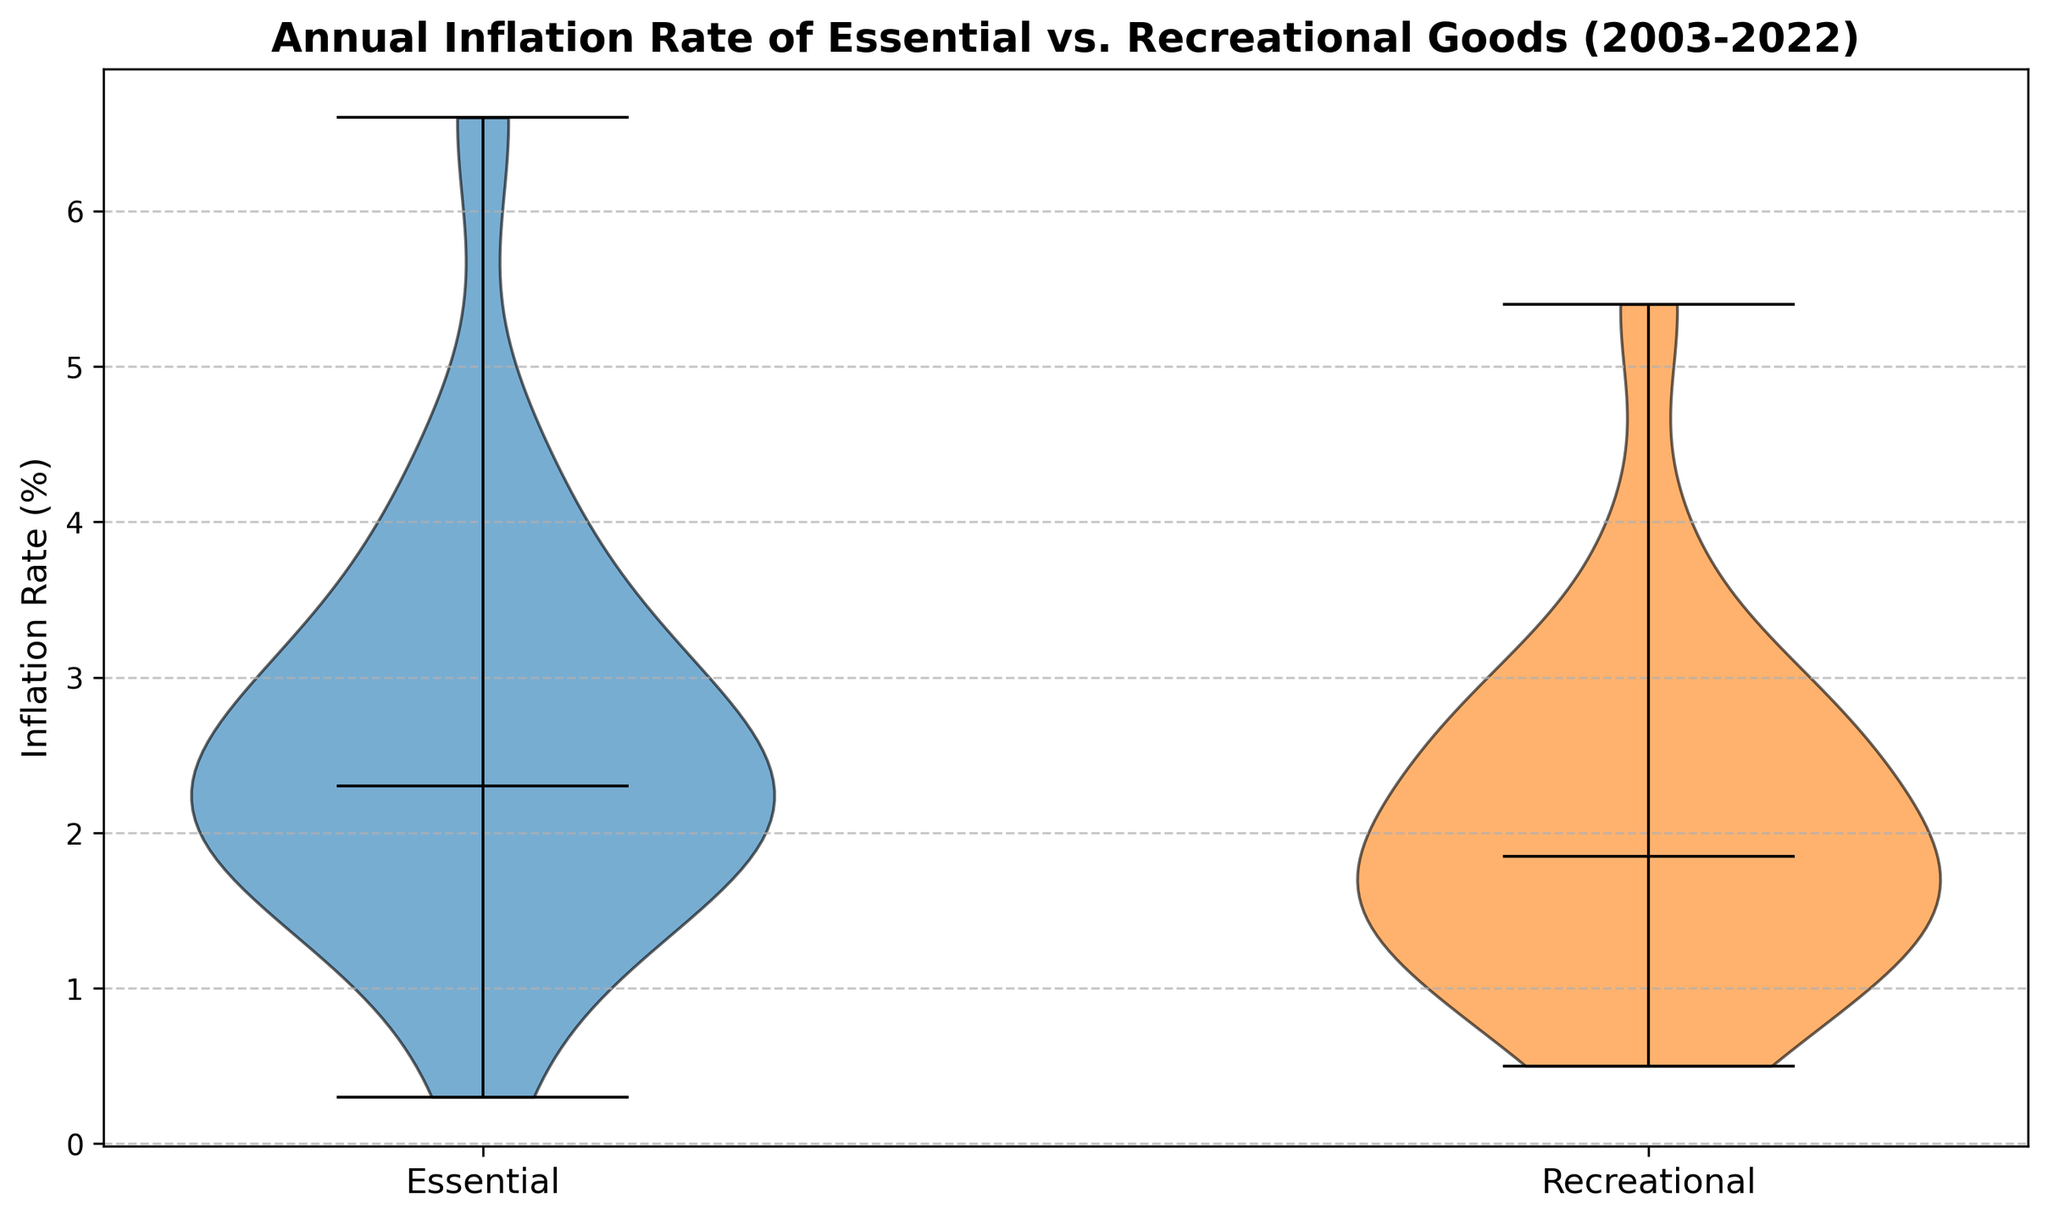What is the median inflation rate for essential goods? The median inflation rate for essential goods is indicated by the central mark in the violin plot for the essential goods category.
Answer: 2.3% Which category has a higher median inflation rate? The violin plot shows that the central mark (median) for essential goods is higher than that for recreational goods.
Answer: Essential goods Which category shows greater variability in inflation rates over the years? The width of the violin plot's body represents variability. Essential goods have a wider spread compared to recreational goods, indicating greater variability.
Answer: Essential goods What is the lowest inflation rate recorded for recreational goods? The bottom tip of the violin plot for recreational goods shows the lowest inflation rate, which is around 0.5%.
Answer: 0.5% How does the highest inflation rate of essential goods compare to that of recreational goods? By observing the top ends of the violin plots, the highest inflation rate for essential goods (around 6.6%) is higher than that for recreational goods (around 5.4%).
Answer: Essential goods' highest rate is higher than recreational goods' What is the difference between the median inflation rates of essential and recreational goods? The median inflation rate for essential goods is around 2.3%, and for recreational goods, it's around 1.7%. The difference is 2.3% - 1.7%.
Answer: 0.6% Is the median inflation rate for recreational goods greater than 2%? Observing the central mark in the violin plot for recreational goods shows that the median inflation rate is less than 2%.
Answer: No Which category's inflation rate had an upper bound closest to or above 4% most often? The upper portion of the violin plot shows that essential goods repeatedly had inflation rates around or above 4% more often than recreational goods.
Answer: Essential goods What is the typical range of inflation rates for recreational goods based on the plot's thickness? The thickest part of the violin plot for recreational goods represents the typical range, which is roughly from 1.5% to 2.5%.
Answer: 1.5%-2.5% Was there any year where the inflation rates of essential and recreational goods were markedly different based on the plot? The violin plot shows that the year 2022 had a significant difference with essential goods at around 6.6% and recreational goods at around 5.4%.
Answer: Yes, in 2022 